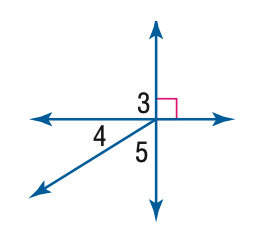Question: m \angle 4 = 32. Find the measure of \angle 3.
Choices:
A. 32
B. 58
C. 90
D. 180
Answer with the letter. Answer: C 